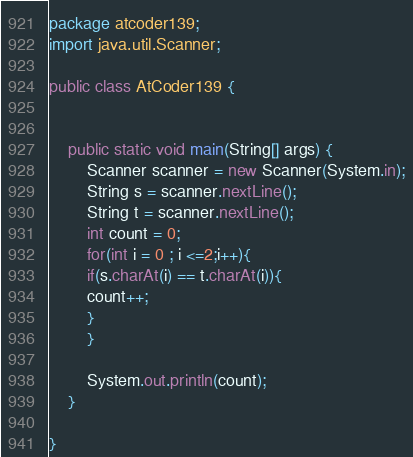<code> <loc_0><loc_0><loc_500><loc_500><_Java_>
package atcoder139;
import java.util.Scanner;

public class AtCoder139 {

   
    public static void main(String[] args) {
        Scanner scanner = new Scanner(System.in);
        String s = scanner.nextLine();
        String t = scanner.nextLine();
        int count = 0;
        for(int i = 0 ; i <=2;i++){
        if(s.charAt(i) == t.charAt(i)){
        count++;
        }
        }
                    
        System.out.println(count);
    }
    
}
</code> 